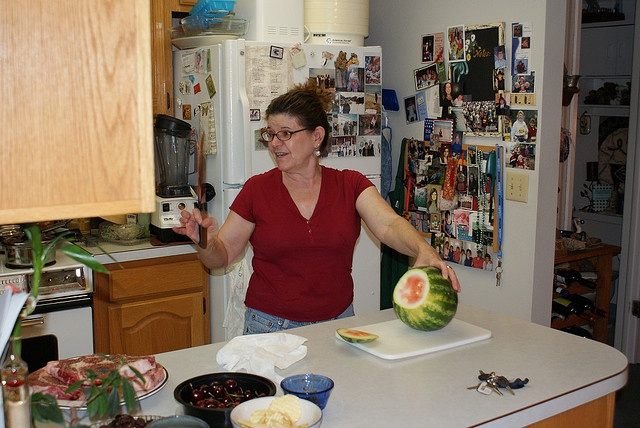Describe the objects in this image and their specific colors. I can see people in tan, maroon, brown, and black tones, refrigerator in tan, darkgray, gray, and lightgray tones, potted plant in tan, black, darkgreen, and gray tones, potted plant in tan, darkgreen, black, and gray tones, and oven in tan, darkgray, black, maroon, and gray tones in this image. 